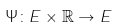<formula> <loc_0><loc_0><loc_500><loc_500>\Psi \colon E \times \mathbb { R } \rightarrow E</formula> 